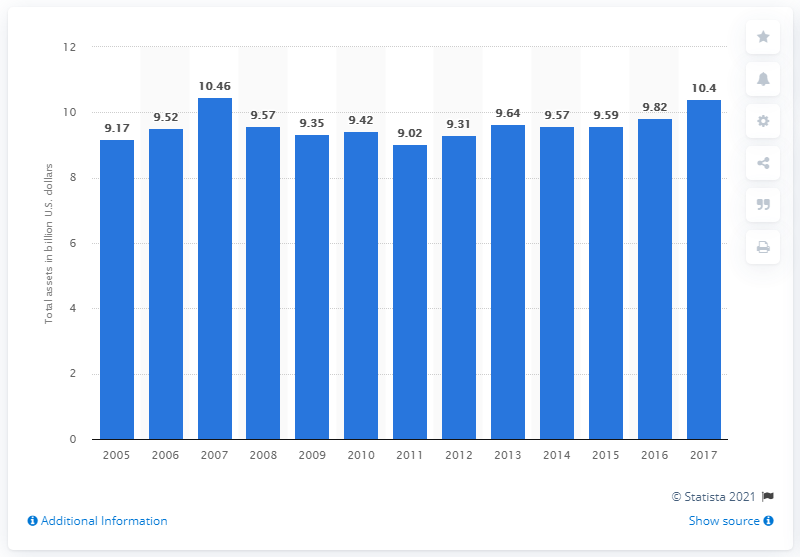Highlight a few significant elements in this photo. In 2017, the total assets of Wyndham Worldwide Corporation were approximately 10.4 billion dollars. 